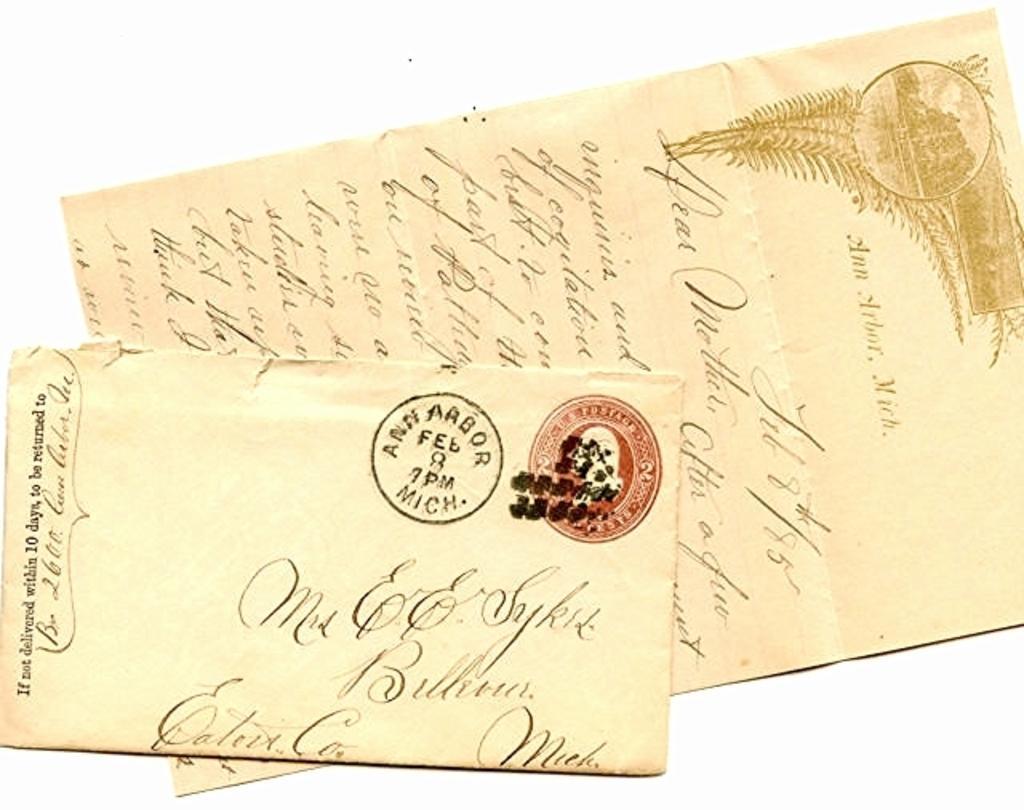Describe this image in one or two sentences. this picture is consists of two letters. 